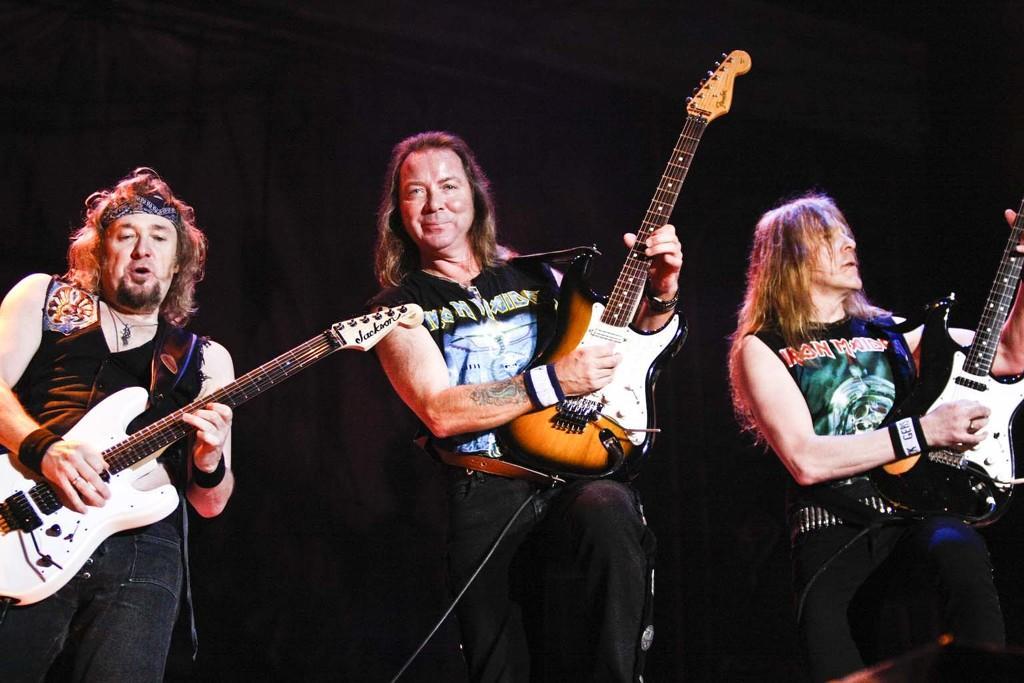Describe this image in one or two sentences. In this image there are three persons standing on the stage and holding a guitars in their hands. Each of them are wearing black t shirts. 